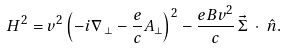Convert formula to latex. <formula><loc_0><loc_0><loc_500><loc_500>H ^ { 2 } = v ^ { 2 } \left ( - i \nabla _ { \, \perp } - \frac { e } { c } { A } _ { \perp } \right ) ^ { 2 } - \frac { e B v ^ { 2 } } { c } \, \vec { \Sigma } \, \cdot \, \hat { n } .</formula> 